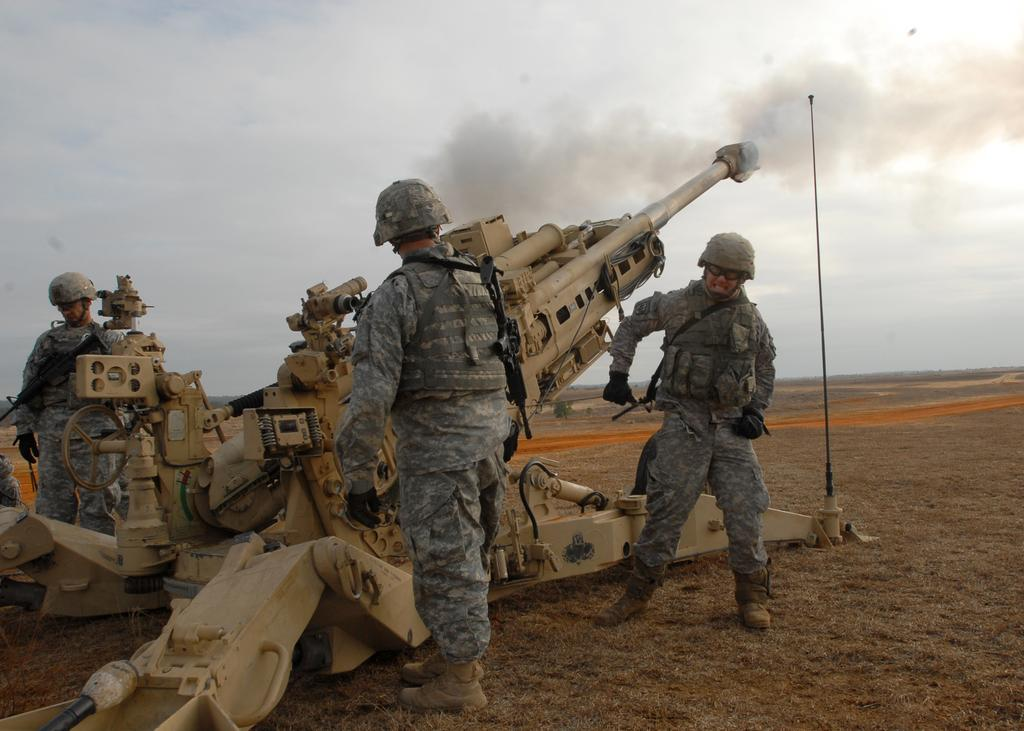How many people are in the image? There are three people in the image. Where are the people standing? The people are standing on a path. What is in front of the people? There is a machine in front of the people. What can be seen coming from the machine? There is smoke visible in the image. What is the condition of the sky in the background? The sky is cloudy in the background. Is there a snail crawling on the path in the image? There is no snail visible in the image. Does the existence of the people in the image prove the existence of a party? The presence of people in the image does not necessarily indicate the existence of a party, as they could be standing on a path for various reasons. 